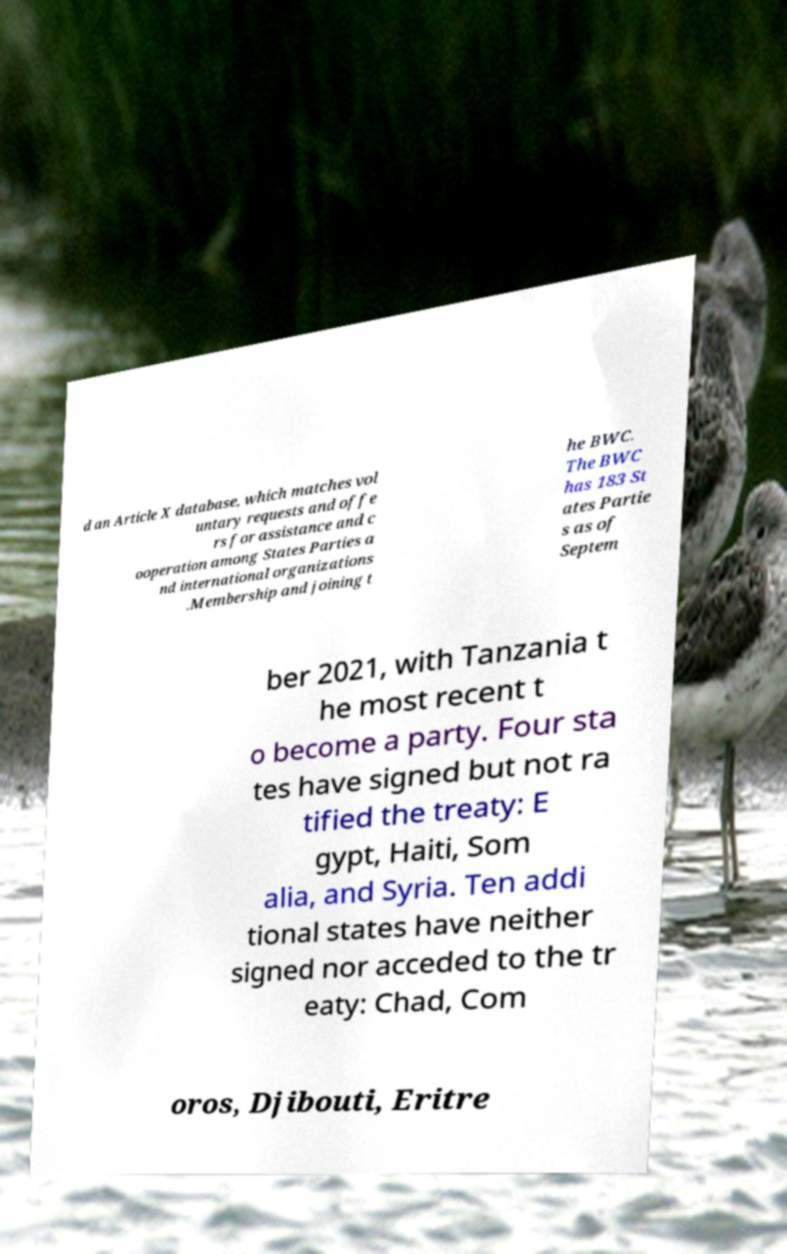Please read and relay the text visible in this image. What does it say? d an Article X database, which matches vol untary requests and offe rs for assistance and c ooperation among States Parties a nd international organizations .Membership and joining t he BWC. The BWC has 183 St ates Partie s as of Septem ber 2021, with Tanzania t he most recent t o become a party. Four sta tes have signed but not ra tified the treaty: E gypt, Haiti, Som alia, and Syria. Ten addi tional states have neither signed nor acceded to the tr eaty: Chad, Com oros, Djibouti, Eritre 